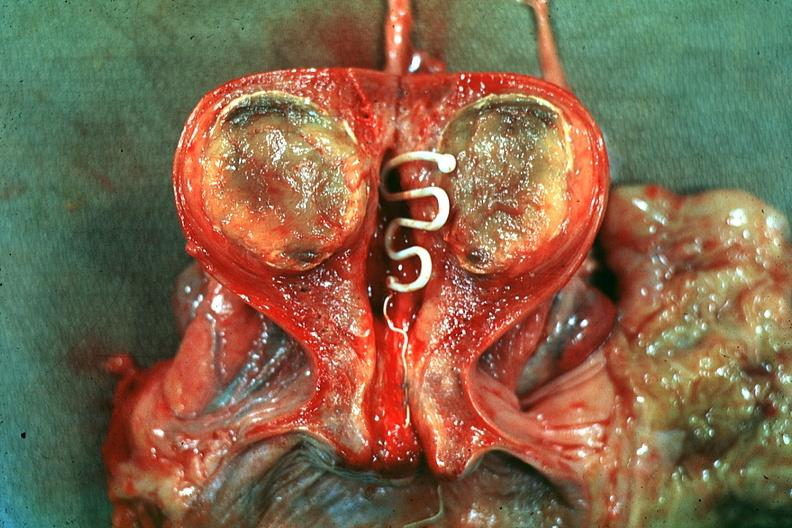s female reproductive present?
Answer the question using a single word or phrase. Yes 